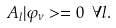Convert formula to latex. <formula><loc_0><loc_0><loc_500><loc_500>A _ { l } | \varphi _ { \nu } > = 0 \text { } \forall l .</formula> 